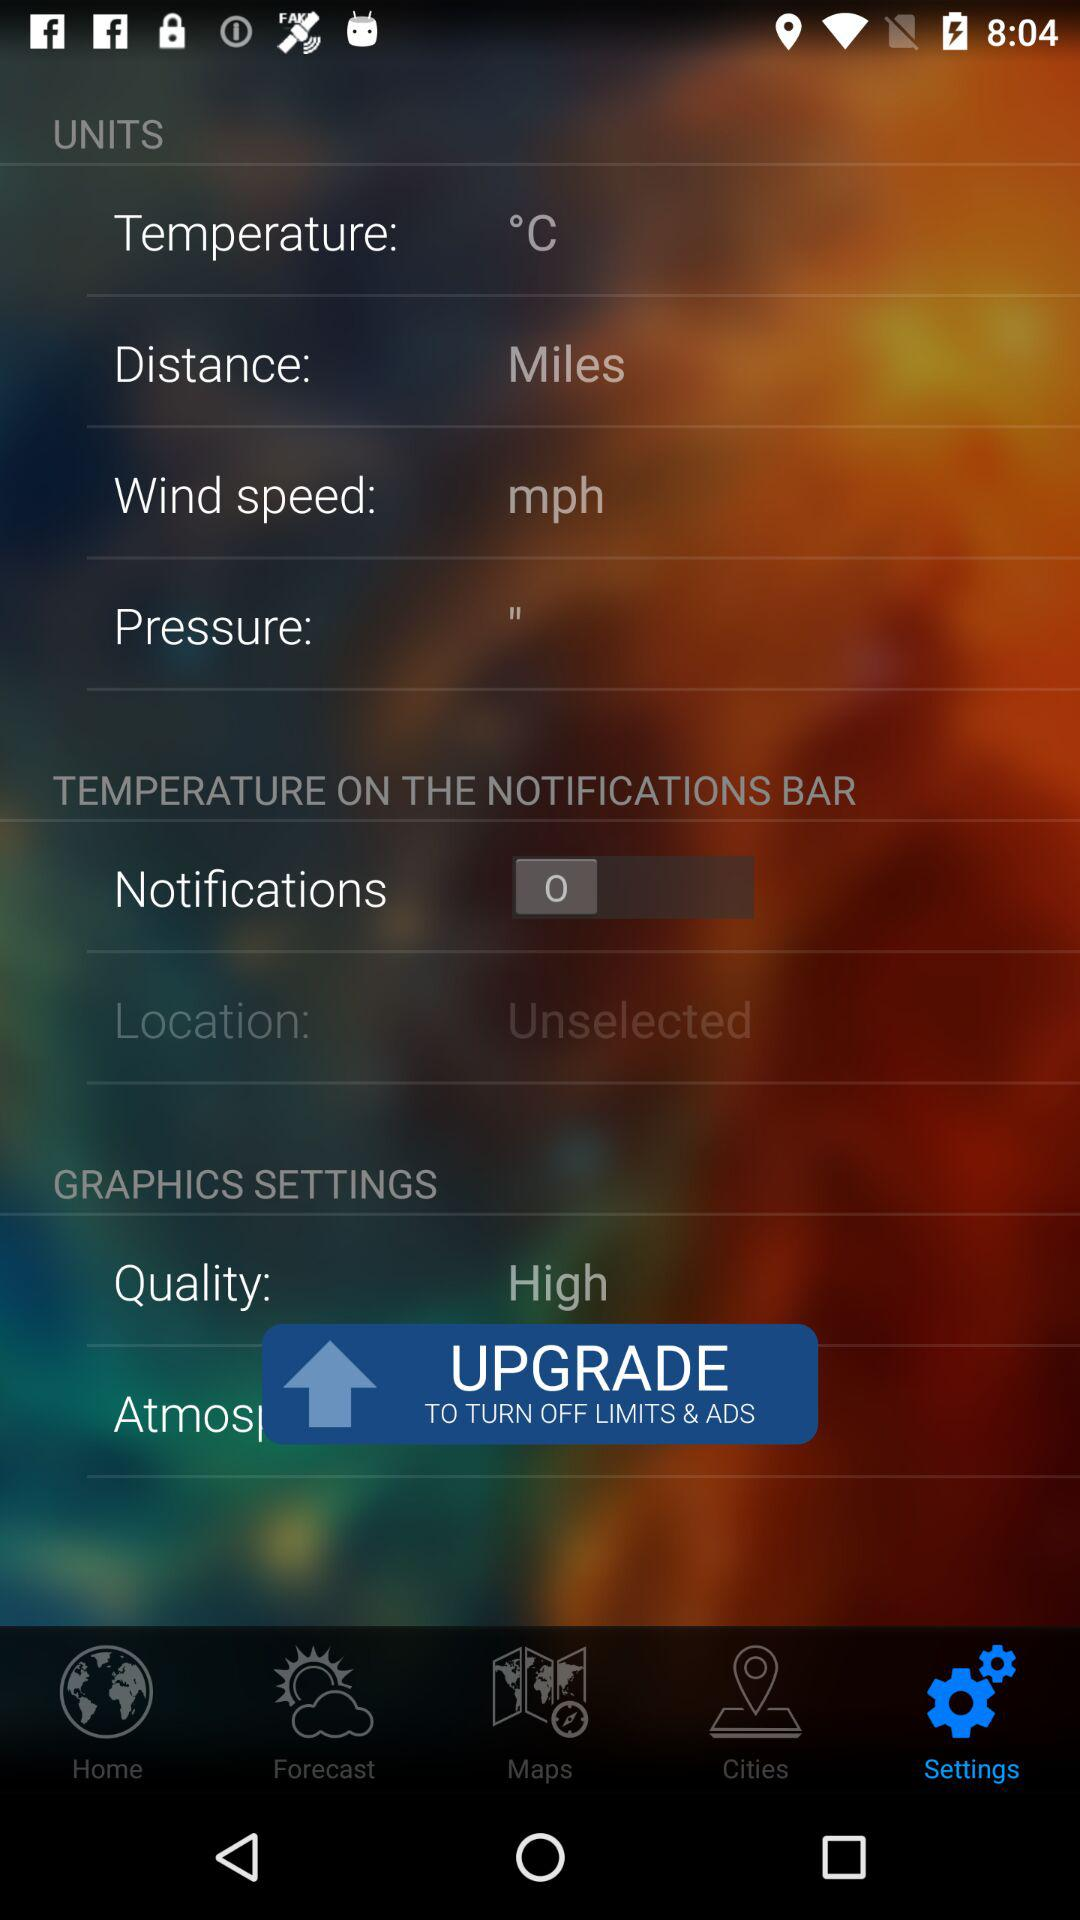What is the selected graphic quality? The selected graphic quality is high. 